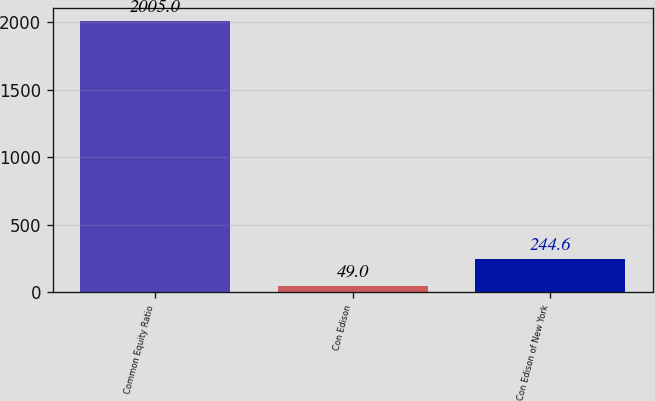Convert chart to OTSL. <chart><loc_0><loc_0><loc_500><loc_500><bar_chart><fcel>Common Equity Ratio<fcel>Con Edison<fcel>Con Edison of New York<nl><fcel>2005<fcel>49<fcel>244.6<nl></chart> 